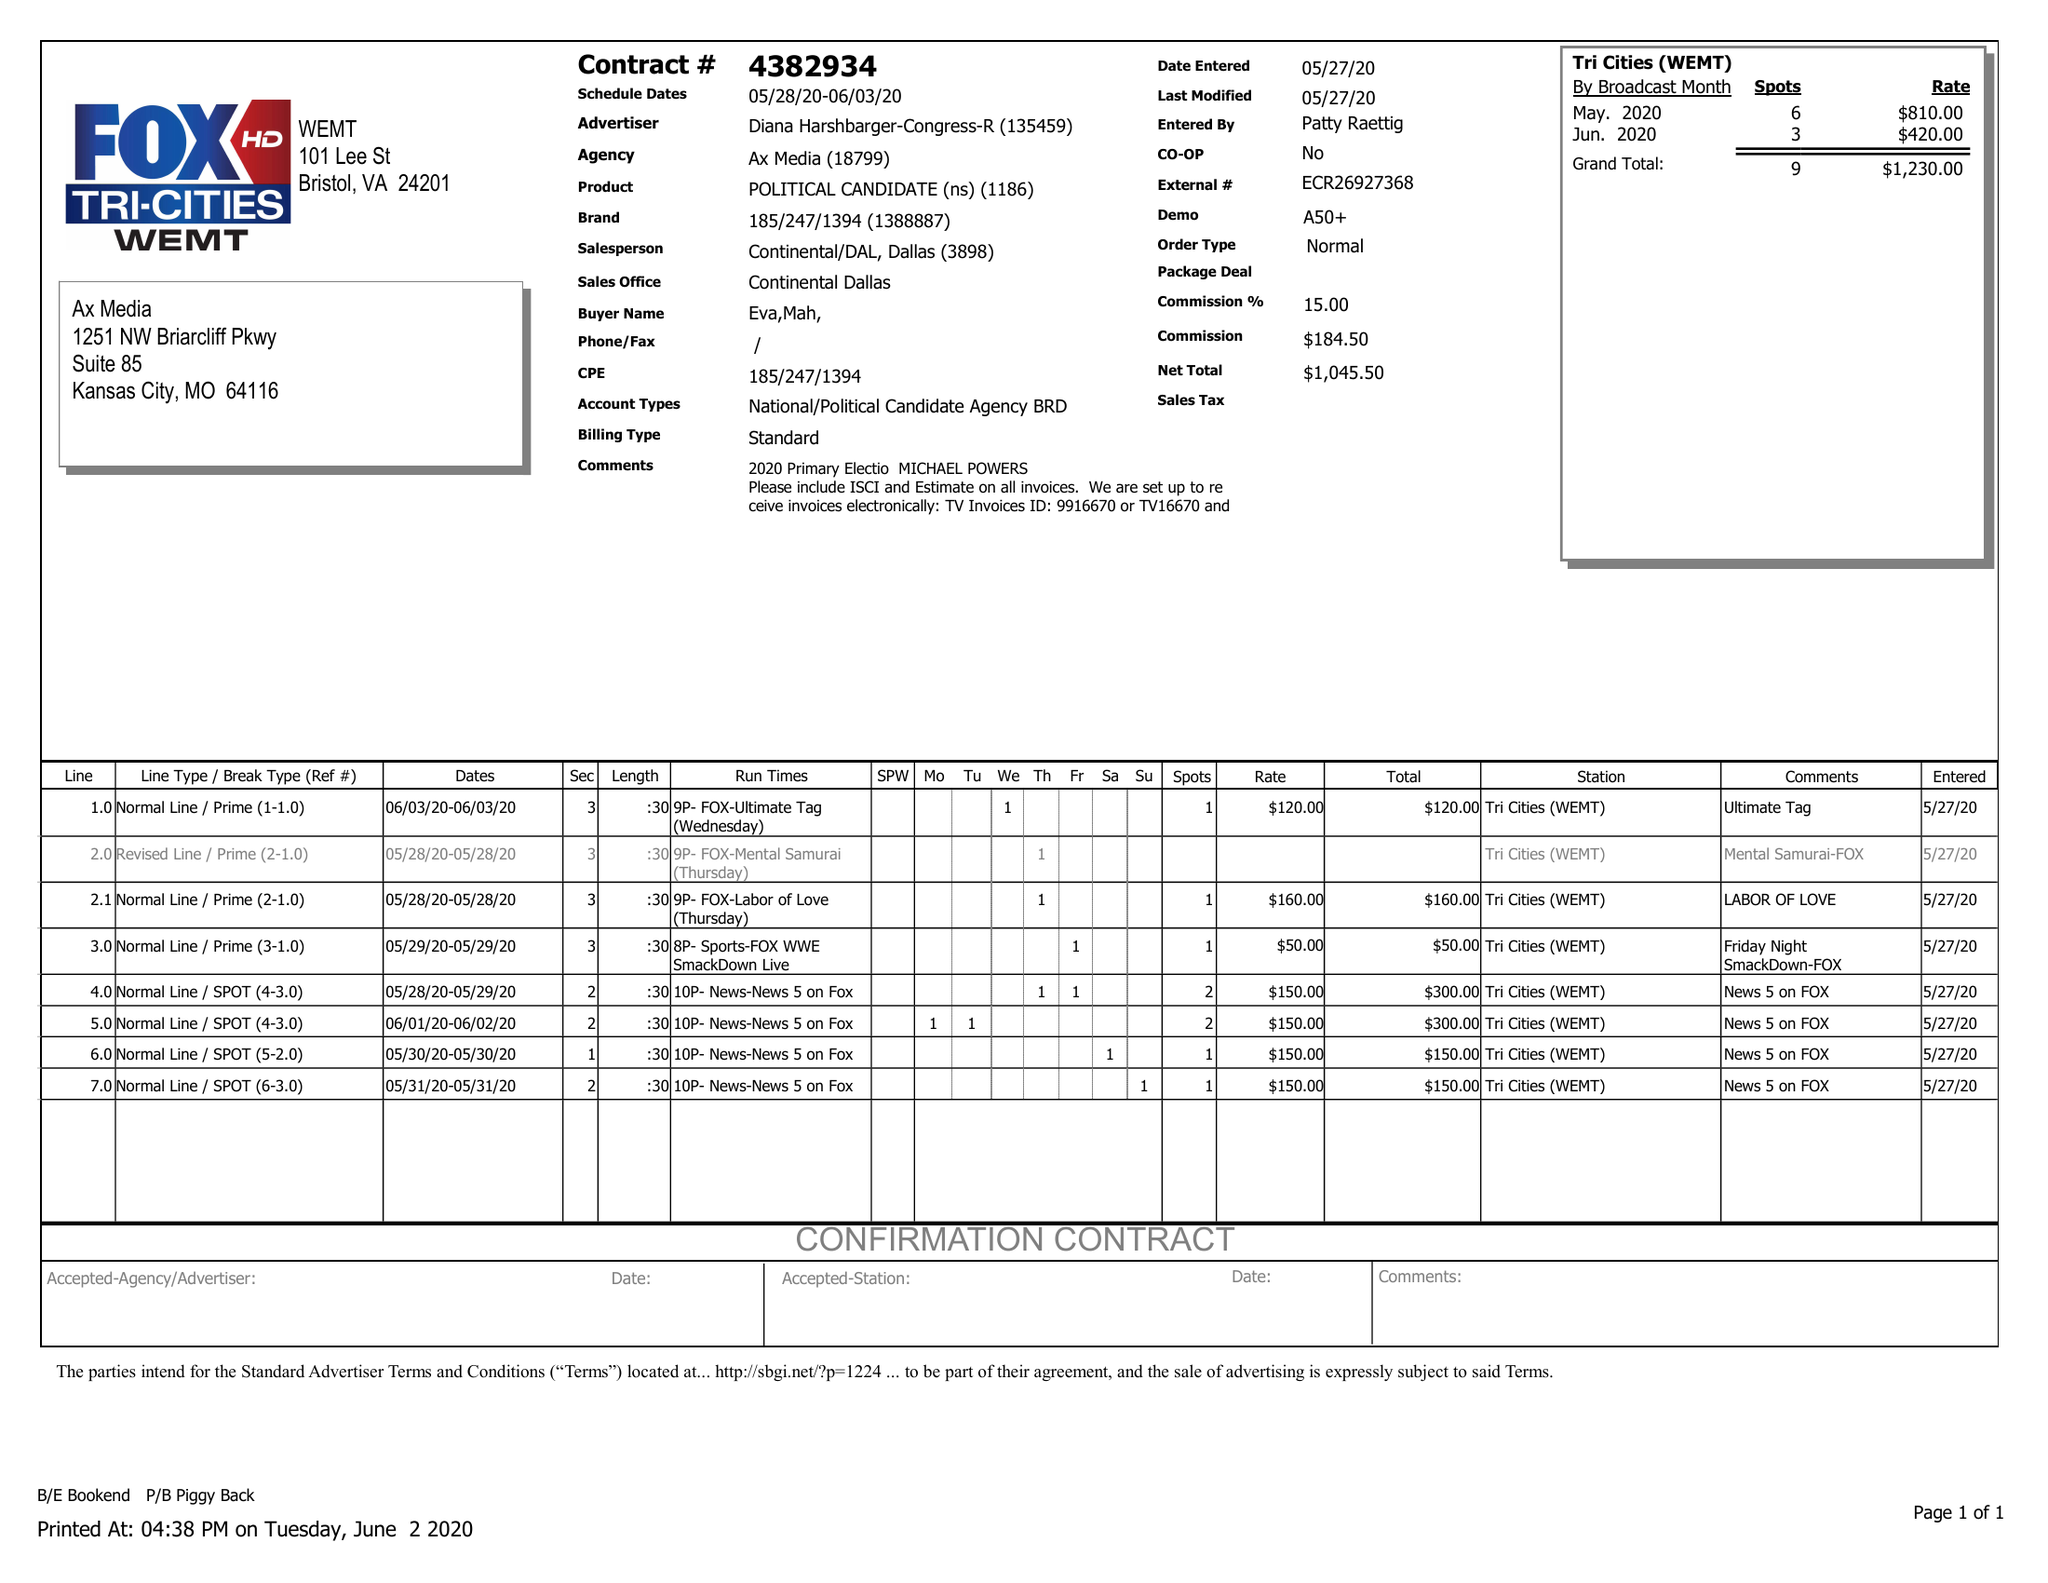What is the value for the flight_from?
Answer the question using a single word or phrase. 05/28/20 